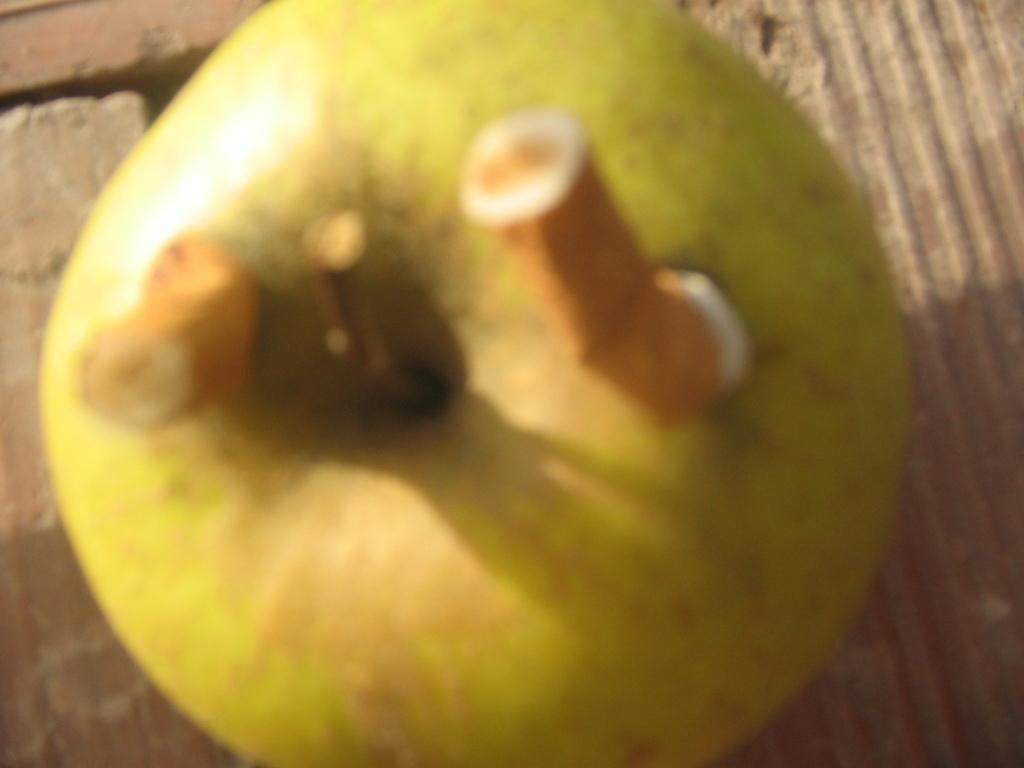In one or two sentences, can you explain what this image depicts? The given image is blurred. In the image we can see an apple and on the apple there are two half cigarettes. 